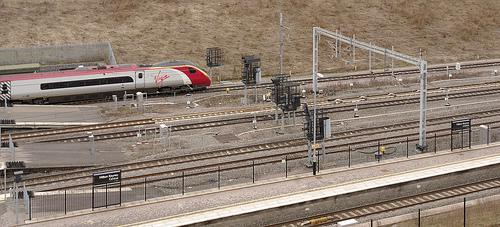Question: what color is in the ground?
Choices:
A. Green.
B. Brown.
C. Black.
D. Red.
Answer with the letter. Answer: B Question: what is on the tracks?
Choices:
A. A train.
B. A wheel.
C. A cart.
D. A car.
Answer with the letter. Answer: A Question: how many trains are in the picture?
Choices:
A. One.
B. Two.
C. Ten.
D. Five.
Answer with the letter. Answer: A Question: how many people are in the picture?
Choices:
A. One.
B. Seven.
C. Nine.
D. Zero.
Answer with the letter. Answer: D 